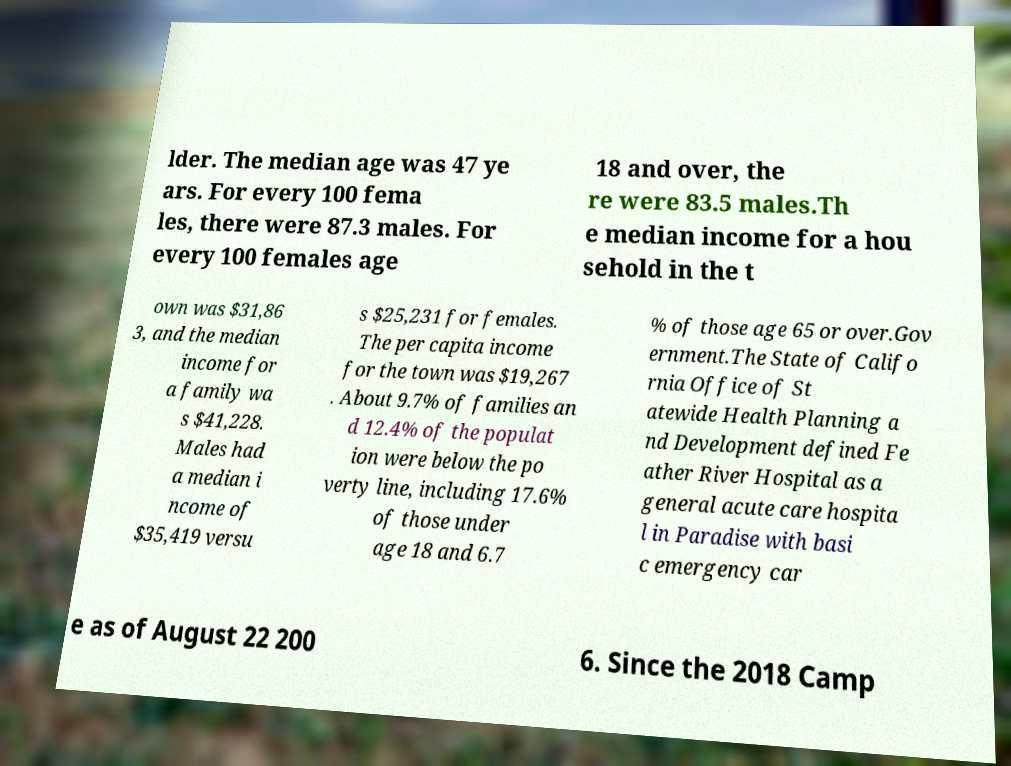Please read and relay the text visible in this image. What does it say? lder. The median age was 47 ye ars. For every 100 fema les, there were 87.3 males. For every 100 females age 18 and over, the re were 83.5 males.Th e median income for a hou sehold in the t own was $31,86 3, and the median income for a family wa s $41,228. Males had a median i ncome of $35,419 versu s $25,231 for females. The per capita income for the town was $19,267 . About 9.7% of families an d 12.4% of the populat ion were below the po verty line, including 17.6% of those under age 18 and 6.7 % of those age 65 or over.Gov ernment.The State of Califo rnia Office of St atewide Health Planning a nd Development defined Fe ather River Hospital as a general acute care hospita l in Paradise with basi c emergency car e as of August 22 200 6. Since the 2018 Camp 